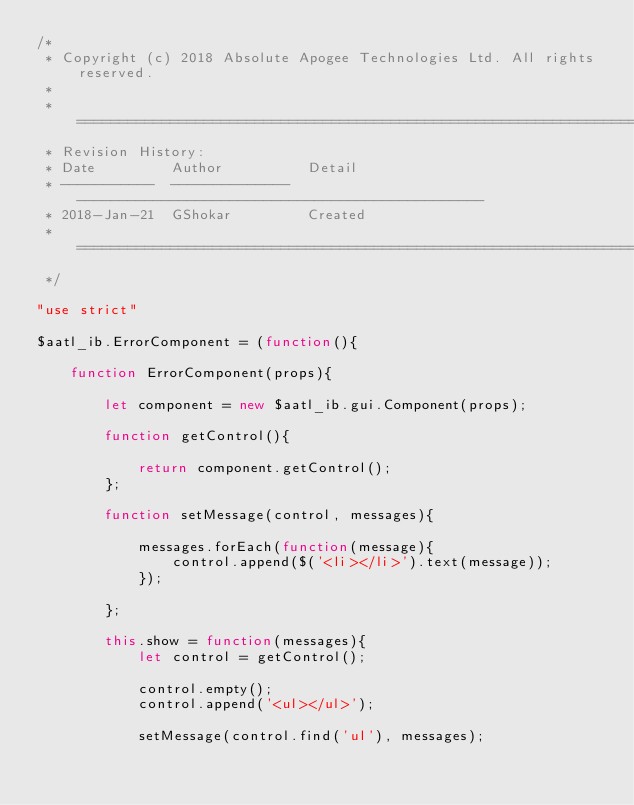<code> <loc_0><loc_0><loc_500><loc_500><_JavaScript_>/* 
 * Copyright (c) 2018 Absolute Apogee Technologies Ltd. All rights reserved.
 * 
 * =============================================================================
 * Revision History:
 * Date         Author          Detail
 * -----------  --------------  ------------------------------------------------
 * 2018-Jan-21  GShokar         Created
 * =============================================================================
 */

"use strict"

$aatl_ib.ErrorComponent = (function(){
    
    function ErrorComponent(props){
                
        let component = new $aatl_ib.gui.Component(props);
        
        function getControl(){
          
            return component.getControl();
        };
                
        function setMessage(control, messages){
            
            messages.forEach(function(message){ 
                control.append($('<li></li>').text(message));
            });
            
        };
        
        this.show = function(messages){
            let control = getControl();
            
            control.empty();
            control.append('<ul></ul>');
            
            setMessage(control.find('ul'), messages);
            </code> 